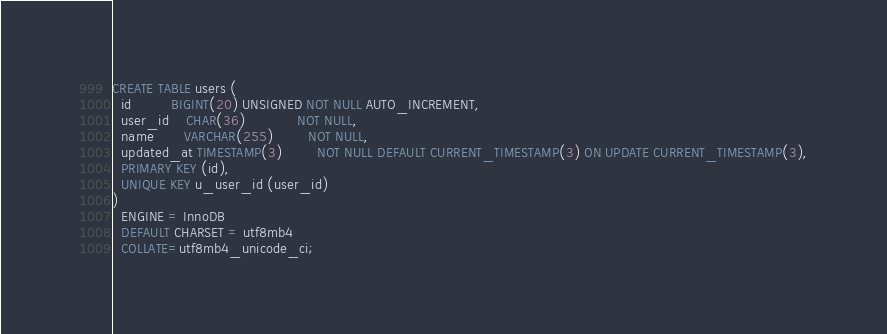Convert code to text. <code><loc_0><loc_0><loc_500><loc_500><_SQL_>CREATE TABLE users (
  id         BIGINT(20) UNSIGNED NOT NULL AUTO_INCREMENT,
  user_id    CHAR(36)            NOT NULL,
  name       VARCHAR(255)        NOT NULL,
  updated_at TIMESTAMP(3)        NOT NULL DEFAULT CURRENT_TIMESTAMP(3) ON UPDATE CURRENT_TIMESTAMP(3),
  PRIMARY KEY (id),
  UNIQUE KEY u_user_id (user_id)
)
  ENGINE = InnoDB
  DEFAULT CHARSET = utf8mb4
  COLLATE=utf8mb4_unicode_ci;
</code> 